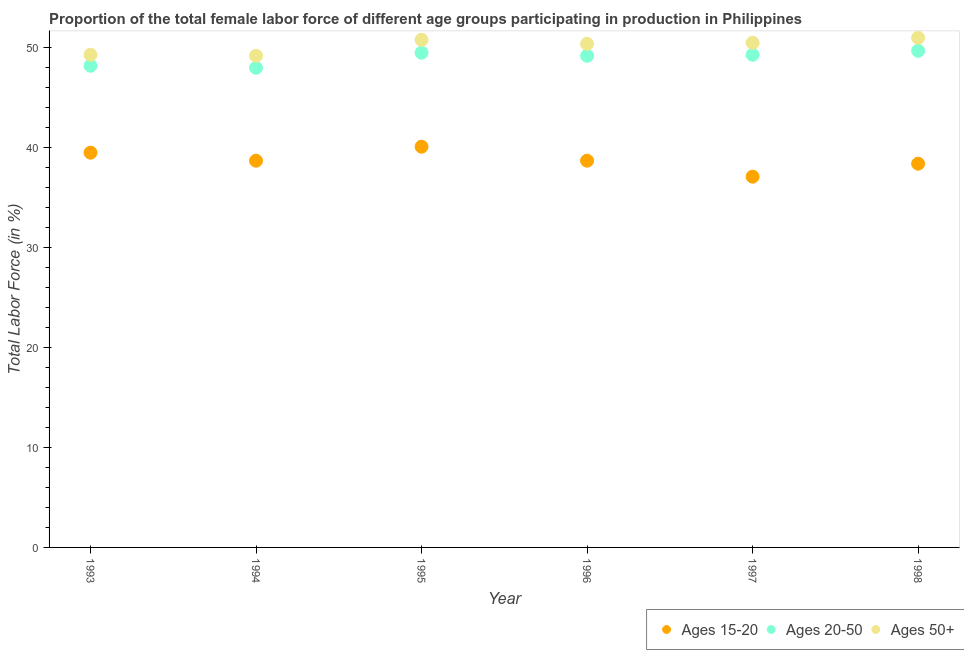How many different coloured dotlines are there?
Ensure brevity in your answer.  3. Is the number of dotlines equal to the number of legend labels?
Provide a succinct answer. Yes. What is the percentage of female labor force within the age group 15-20 in 1998?
Give a very brief answer. 38.4. Across all years, what is the maximum percentage of female labor force above age 50?
Make the answer very short. 51. Across all years, what is the minimum percentage of female labor force above age 50?
Ensure brevity in your answer.  49.2. What is the total percentage of female labor force above age 50 in the graph?
Provide a short and direct response. 301.2. What is the average percentage of female labor force above age 50 per year?
Keep it short and to the point. 50.2. In the year 1993, what is the difference between the percentage of female labor force within the age group 20-50 and percentage of female labor force above age 50?
Make the answer very short. -1.1. What is the ratio of the percentage of female labor force within the age group 20-50 in 1995 to that in 1998?
Your answer should be compact. 1. Is the percentage of female labor force within the age group 15-20 in 1995 less than that in 1997?
Give a very brief answer. No. What is the difference between the highest and the second highest percentage of female labor force above age 50?
Provide a succinct answer. 0.2. What is the difference between the highest and the lowest percentage of female labor force within the age group 20-50?
Ensure brevity in your answer.  1.7. In how many years, is the percentage of female labor force within the age group 15-20 greater than the average percentage of female labor force within the age group 15-20 taken over all years?
Your response must be concise. 2. Is the sum of the percentage of female labor force within the age group 15-20 in 1994 and 1996 greater than the maximum percentage of female labor force within the age group 20-50 across all years?
Make the answer very short. Yes. Is the percentage of female labor force above age 50 strictly greater than the percentage of female labor force within the age group 15-20 over the years?
Offer a very short reply. Yes. Is the percentage of female labor force above age 50 strictly less than the percentage of female labor force within the age group 15-20 over the years?
Provide a short and direct response. No. How many years are there in the graph?
Make the answer very short. 6. Are the values on the major ticks of Y-axis written in scientific E-notation?
Make the answer very short. No. Does the graph contain any zero values?
Provide a succinct answer. No. Where does the legend appear in the graph?
Give a very brief answer. Bottom right. How are the legend labels stacked?
Offer a terse response. Horizontal. What is the title of the graph?
Make the answer very short. Proportion of the total female labor force of different age groups participating in production in Philippines. What is the label or title of the X-axis?
Offer a very short reply. Year. What is the label or title of the Y-axis?
Ensure brevity in your answer.  Total Labor Force (in %). What is the Total Labor Force (in %) in Ages 15-20 in 1993?
Your answer should be very brief. 39.5. What is the Total Labor Force (in %) in Ages 20-50 in 1993?
Give a very brief answer. 48.2. What is the Total Labor Force (in %) in Ages 50+ in 1993?
Make the answer very short. 49.3. What is the Total Labor Force (in %) of Ages 15-20 in 1994?
Keep it short and to the point. 38.7. What is the Total Labor Force (in %) in Ages 50+ in 1994?
Offer a terse response. 49.2. What is the Total Labor Force (in %) of Ages 15-20 in 1995?
Provide a succinct answer. 40.1. What is the Total Labor Force (in %) in Ages 20-50 in 1995?
Provide a succinct answer. 49.5. What is the Total Labor Force (in %) in Ages 50+ in 1995?
Provide a short and direct response. 50.8. What is the Total Labor Force (in %) of Ages 15-20 in 1996?
Provide a succinct answer. 38.7. What is the Total Labor Force (in %) in Ages 20-50 in 1996?
Your response must be concise. 49.2. What is the Total Labor Force (in %) of Ages 50+ in 1996?
Offer a very short reply. 50.4. What is the Total Labor Force (in %) of Ages 15-20 in 1997?
Provide a short and direct response. 37.1. What is the Total Labor Force (in %) of Ages 20-50 in 1997?
Make the answer very short. 49.3. What is the Total Labor Force (in %) of Ages 50+ in 1997?
Your response must be concise. 50.5. What is the Total Labor Force (in %) of Ages 15-20 in 1998?
Your answer should be compact. 38.4. What is the Total Labor Force (in %) in Ages 20-50 in 1998?
Your response must be concise. 49.7. Across all years, what is the maximum Total Labor Force (in %) in Ages 15-20?
Provide a short and direct response. 40.1. Across all years, what is the maximum Total Labor Force (in %) of Ages 20-50?
Provide a succinct answer. 49.7. Across all years, what is the minimum Total Labor Force (in %) of Ages 15-20?
Your answer should be very brief. 37.1. Across all years, what is the minimum Total Labor Force (in %) in Ages 20-50?
Keep it short and to the point. 48. Across all years, what is the minimum Total Labor Force (in %) in Ages 50+?
Give a very brief answer. 49.2. What is the total Total Labor Force (in %) of Ages 15-20 in the graph?
Your answer should be compact. 232.5. What is the total Total Labor Force (in %) in Ages 20-50 in the graph?
Provide a succinct answer. 293.9. What is the total Total Labor Force (in %) of Ages 50+ in the graph?
Offer a terse response. 301.2. What is the difference between the Total Labor Force (in %) of Ages 15-20 in 1993 and that in 1994?
Your answer should be very brief. 0.8. What is the difference between the Total Labor Force (in %) in Ages 20-50 in 1993 and that in 1994?
Make the answer very short. 0.2. What is the difference between the Total Labor Force (in %) in Ages 50+ in 1993 and that in 1995?
Offer a very short reply. -1.5. What is the difference between the Total Labor Force (in %) of Ages 15-20 in 1993 and that in 1996?
Keep it short and to the point. 0.8. What is the difference between the Total Labor Force (in %) in Ages 20-50 in 1993 and that in 1996?
Keep it short and to the point. -1. What is the difference between the Total Labor Force (in %) of Ages 50+ in 1993 and that in 1996?
Offer a terse response. -1.1. What is the difference between the Total Labor Force (in %) of Ages 50+ in 1993 and that in 1998?
Provide a succinct answer. -1.7. What is the difference between the Total Labor Force (in %) in Ages 50+ in 1994 and that in 1995?
Offer a very short reply. -1.6. What is the difference between the Total Labor Force (in %) of Ages 50+ in 1994 and that in 1996?
Make the answer very short. -1.2. What is the difference between the Total Labor Force (in %) of Ages 15-20 in 1994 and that in 1997?
Offer a terse response. 1.6. What is the difference between the Total Labor Force (in %) of Ages 20-50 in 1994 and that in 1997?
Offer a very short reply. -1.3. What is the difference between the Total Labor Force (in %) in Ages 50+ in 1994 and that in 1997?
Keep it short and to the point. -1.3. What is the difference between the Total Labor Force (in %) of Ages 15-20 in 1994 and that in 1998?
Keep it short and to the point. 0.3. What is the difference between the Total Labor Force (in %) in Ages 20-50 in 1994 and that in 1998?
Offer a very short reply. -1.7. What is the difference between the Total Labor Force (in %) of Ages 15-20 in 1995 and that in 1996?
Your answer should be very brief. 1.4. What is the difference between the Total Labor Force (in %) of Ages 50+ in 1995 and that in 1997?
Ensure brevity in your answer.  0.3. What is the difference between the Total Labor Force (in %) of Ages 15-20 in 1995 and that in 1998?
Your answer should be very brief. 1.7. What is the difference between the Total Labor Force (in %) of Ages 50+ in 1995 and that in 1998?
Your answer should be very brief. -0.2. What is the difference between the Total Labor Force (in %) of Ages 20-50 in 1996 and that in 1997?
Provide a short and direct response. -0.1. What is the difference between the Total Labor Force (in %) of Ages 15-20 in 1996 and that in 1998?
Give a very brief answer. 0.3. What is the difference between the Total Labor Force (in %) of Ages 20-50 in 1996 and that in 1998?
Provide a succinct answer. -0.5. What is the difference between the Total Labor Force (in %) of Ages 50+ in 1996 and that in 1998?
Provide a succinct answer. -0.6. What is the difference between the Total Labor Force (in %) in Ages 15-20 in 1997 and that in 1998?
Your answer should be very brief. -1.3. What is the difference between the Total Labor Force (in %) of Ages 50+ in 1997 and that in 1998?
Your answer should be compact. -0.5. What is the difference between the Total Labor Force (in %) of Ages 15-20 in 1993 and the Total Labor Force (in %) of Ages 50+ in 1994?
Offer a very short reply. -9.7. What is the difference between the Total Labor Force (in %) in Ages 15-20 in 1993 and the Total Labor Force (in %) in Ages 50+ in 1996?
Your answer should be compact. -10.9. What is the difference between the Total Labor Force (in %) in Ages 20-50 in 1993 and the Total Labor Force (in %) in Ages 50+ in 1996?
Your answer should be compact. -2.2. What is the difference between the Total Labor Force (in %) of Ages 15-20 in 1993 and the Total Labor Force (in %) of Ages 50+ in 1997?
Ensure brevity in your answer.  -11. What is the difference between the Total Labor Force (in %) of Ages 15-20 in 1993 and the Total Labor Force (in %) of Ages 20-50 in 1998?
Keep it short and to the point. -10.2. What is the difference between the Total Labor Force (in %) in Ages 20-50 in 1993 and the Total Labor Force (in %) in Ages 50+ in 1998?
Offer a terse response. -2.8. What is the difference between the Total Labor Force (in %) in Ages 15-20 in 1994 and the Total Labor Force (in %) in Ages 50+ in 1995?
Give a very brief answer. -12.1. What is the difference between the Total Labor Force (in %) in Ages 15-20 in 1994 and the Total Labor Force (in %) in Ages 20-50 in 1996?
Provide a succinct answer. -10.5. What is the difference between the Total Labor Force (in %) in Ages 20-50 in 1994 and the Total Labor Force (in %) in Ages 50+ in 1996?
Keep it short and to the point. -2.4. What is the difference between the Total Labor Force (in %) in Ages 20-50 in 1994 and the Total Labor Force (in %) in Ages 50+ in 1997?
Keep it short and to the point. -2.5. What is the difference between the Total Labor Force (in %) of Ages 20-50 in 1994 and the Total Labor Force (in %) of Ages 50+ in 1998?
Keep it short and to the point. -3. What is the difference between the Total Labor Force (in %) in Ages 15-20 in 1995 and the Total Labor Force (in %) in Ages 50+ in 1996?
Make the answer very short. -10.3. What is the difference between the Total Labor Force (in %) of Ages 20-50 in 1995 and the Total Labor Force (in %) of Ages 50+ in 1996?
Keep it short and to the point. -0.9. What is the difference between the Total Labor Force (in %) in Ages 20-50 in 1995 and the Total Labor Force (in %) in Ages 50+ in 1998?
Your response must be concise. -1.5. What is the difference between the Total Labor Force (in %) of Ages 20-50 in 1996 and the Total Labor Force (in %) of Ages 50+ in 1997?
Offer a terse response. -1.3. What is the difference between the Total Labor Force (in %) of Ages 15-20 in 1996 and the Total Labor Force (in %) of Ages 20-50 in 1998?
Make the answer very short. -11. What is the difference between the Total Labor Force (in %) of Ages 15-20 in 1996 and the Total Labor Force (in %) of Ages 50+ in 1998?
Provide a short and direct response. -12.3. What is the difference between the Total Labor Force (in %) of Ages 20-50 in 1996 and the Total Labor Force (in %) of Ages 50+ in 1998?
Ensure brevity in your answer.  -1.8. What is the difference between the Total Labor Force (in %) of Ages 15-20 in 1997 and the Total Labor Force (in %) of Ages 20-50 in 1998?
Make the answer very short. -12.6. What is the difference between the Total Labor Force (in %) of Ages 15-20 in 1997 and the Total Labor Force (in %) of Ages 50+ in 1998?
Keep it short and to the point. -13.9. What is the average Total Labor Force (in %) in Ages 15-20 per year?
Offer a terse response. 38.75. What is the average Total Labor Force (in %) in Ages 20-50 per year?
Your response must be concise. 48.98. What is the average Total Labor Force (in %) of Ages 50+ per year?
Keep it short and to the point. 50.2. In the year 1993, what is the difference between the Total Labor Force (in %) in Ages 20-50 and Total Labor Force (in %) in Ages 50+?
Your answer should be very brief. -1.1. In the year 1994, what is the difference between the Total Labor Force (in %) of Ages 15-20 and Total Labor Force (in %) of Ages 50+?
Keep it short and to the point. -10.5. In the year 1996, what is the difference between the Total Labor Force (in %) in Ages 15-20 and Total Labor Force (in %) in Ages 20-50?
Offer a very short reply. -10.5. In the year 1997, what is the difference between the Total Labor Force (in %) in Ages 15-20 and Total Labor Force (in %) in Ages 20-50?
Your response must be concise. -12.2. In the year 1997, what is the difference between the Total Labor Force (in %) in Ages 15-20 and Total Labor Force (in %) in Ages 50+?
Your answer should be compact. -13.4. What is the ratio of the Total Labor Force (in %) of Ages 15-20 in 1993 to that in 1994?
Make the answer very short. 1.02. What is the ratio of the Total Labor Force (in %) in Ages 20-50 in 1993 to that in 1994?
Make the answer very short. 1. What is the ratio of the Total Labor Force (in %) in Ages 50+ in 1993 to that in 1994?
Ensure brevity in your answer.  1. What is the ratio of the Total Labor Force (in %) of Ages 15-20 in 1993 to that in 1995?
Offer a terse response. 0.98. What is the ratio of the Total Labor Force (in %) of Ages 20-50 in 1993 to that in 1995?
Provide a succinct answer. 0.97. What is the ratio of the Total Labor Force (in %) in Ages 50+ in 1993 to that in 1995?
Provide a short and direct response. 0.97. What is the ratio of the Total Labor Force (in %) in Ages 15-20 in 1993 to that in 1996?
Provide a short and direct response. 1.02. What is the ratio of the Total Labor Force (in %) in Ages 20-50 in 1993 to that in 1996?
Your response must be concise. 0.98. What is the ratio of the Total Labor Force (in %) of Ages 50+ in 1993 to that in 1996?
Offer a terse response. 0.98. What is the ratio of the Total Labor Force (in %) of Ages 15-20 in 1993 to that in 1997?
Provide a short and direct response. 1.06. What is the ratio of the Total Labor Force (in %) in Ages 20-50 in 1993 to that in 1997?
Offer a very short reply. 0.98. What is the ratio of the Total Labor Force (in %) in Ages 50+ in 1993 to that in 1997?
Your response must be concise. 0.98. What is the ratio of the Total Labor Force (in %) of Ages 15-20 in 1993 to that in 1998?
Make the answer very short. 1.03. What is the ratio of the Total Labor Force (in %) of Ages 20-50 in 1993 to that in 1998?
Make the answer very short. 0.97. What is the ratio of the Total Labor Force (in %) in Ages 50+ in 1993 to that in 1998?
Ensure brevity in your answer.  0.97. What is the ratio of the Total Labor Force (in %) in Ages 15-20 in 1994 to that in 1995?
Ensure brevity in your answer.  0.97. What is the ratio of the Total Labor Force (in %) in Ages 20-50 in 1994 to that in 1995?
Offer a terse response. 0.97. What is the ratio of the Total Labor Force (in %) in Ages 50+ in 1994 to that in 1995?
Your answer should be compact. 0.97. What is the ratio of the Total Labor Force (in %) in Ages 15-20 in 1994 to that in 1996?
Make the answer very short. 1. What is the ratio of the Total Labor Force (in %) of Ages 20-50 in 1994 to that in 1996?
Provide a succinct answer. 0.98. What is the ratio of the Total Labor Force (in %) in Ages 50+ in 1994 to that in 1996?
Give a very brief answer. 0.98. What is the ratio of the Total Labor Force (in %) of Ages 15-20 in 1994 to that in 1997?
Keep it short and to the point. 1.04. What is the ratio of the Total Labor Force (in %) in Ages 20-50 in 1994 to that in 1997?
Give a very brief answer. 0.97. What is the ratio of the Total Labor Force (in %) in Ages 50+ in 1994 to that in 1997?
Your answer should be compact. 0.97. What is the ratio of the Total Labor Force (in %) of Ages 15-20 in 1994 to that in 1998?
Provide a succinct answer. 1.01. What is the ratio of the Total Labor Force (in %) of Ages 20-50 in 1994 to that in 1998?
Offer a very short reply. 0.97. What is the ratio of the Total Labor Force (in %) in Ages 50+ in 1994 to that in 1998?
Provide a short and direct response. 0.96. What is the ratio of the Total Labor Force (in %) of Ages 15-20 in 1995 to that in 1996?
Keep it short and to the point. 1.04. What is the ratio of the Total Labor Force (in %) of Ages 50+ in 1995 to that in 1996?
Your response must be concise. 1.01. What is the ratio of the Total Labor Force (in %) of Ages 15-20 in 1995 to that in 1997?
Make the answer very short. 1.08. What is the ratio of the Total Labor Force (in %) in Ages 50+ in 1995 to that in 1997?
Offer a very short reply. 1.01. What is the ratio of the Total Labor Force (in %) of Ages 15-20 in 1995 to that in 1998?
Offer a terse response. 1.04. What is the ratio of the Total Labor Force (in %) in Ages 20-50 in 1995 to that in 1998?
Make the answer very short. 1. What is the ratio of the Total Labor Force (in %) in Ages 15-20 in 1996 to that in 1997?
Give a very brief answer. 1.04. What is the ratio of the Total Labor Force (in %) in Ages 20-50 in 1996 to that in 1997?
Make the answer very short. 1. What is the ratio of the Total Labor Force (in %) of Ages 50+ in 1996 to that in 1997?
Your response must be concise. 1. What is the ratio of the Total Labor Force (in %) of Ages 15-20 in 1996 to that in 1998?
Provide a short and direct response. 1.01. What is the ratio of the Total Labor Force (in %) in Ages 15-20 in 1997 to that in 1998?
Keep it short and to the point. 0.97. What is the ratio of the Total Labor Force (in %) of Ages 50+ in 1997 to that in 1998?
Offer a very short reply. 0.99. What is the difference between the highest and the second highest Total Labor Force (in %) of Ages 20-50?
Provide a short and direct response. 0.2. What is the difference between the highest and the second highest Total Labor Force (in %) in Ages 50+?
Provide a short and direct response. 0.2. What is the difference between the highest and the lowest Total Labor Force (in %) in Ages 20-50?
Keep it short and to the point. 1.7. 